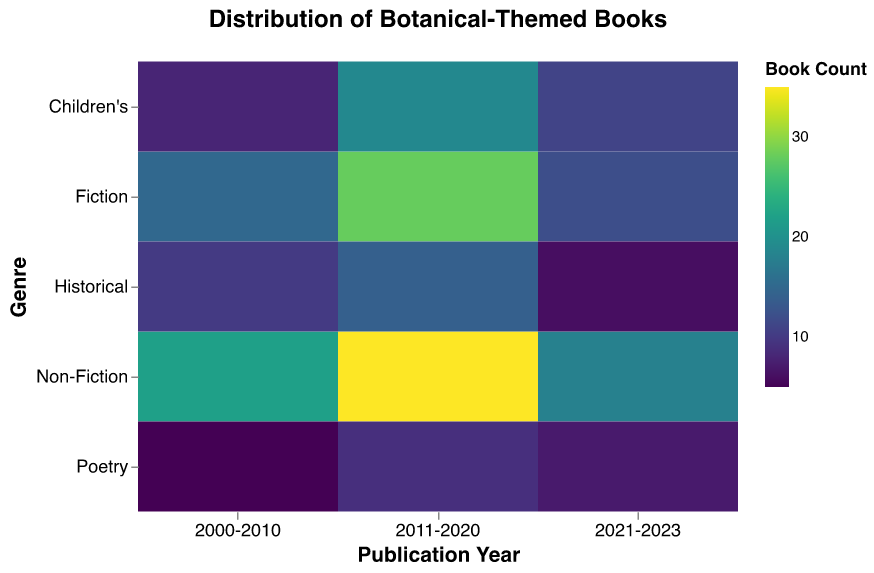What is the title of the figure? The title of the figure is typically displayed prominently at the top of the plot. It provides an overview of what the plot is depicting.
Answer: Distribution of Botanical-Themed Books Which genre has the highest number of botanical-themed books published between 2011-2020? To find this, look for the segment representing the year 2011-2020 and compare the color intensities corresponding to each genre. The darker the color, the higher the book count.
Answer: Non-Fiction How many botanical-themed Historical books were published between 2000-2010? Locate the "Historical" genre along the y-axis and then find the book count for the year 2000-2010 by identifying the color intensity.
Answer: 10 What is the total number of botanical-themed books published in Fiction between 2000-2023? Add the book counts for Fiction in each of the time periods provided: (15 from 2000-2010) + (28 from 2011-2020) + (12 from 2021-2023). Sum them up to get the total number of books.
Answer: 55 Which genre had the smallest number of botanical-themed books published between 2000-2010? Compare the color intensities of all segments for the years 2000-2010. The segment with the lightest color (lowest intensity) represents the smallest number of books.
Answer: Poetry Compare the total number of botanical-themed Non-Fiction books to the total number of botanical-themed Children's books across all years. Which genre had more books printed? Sum the book counts for Non-Fiction and Children's books across all provided time periods, then compare the totals. 
Non-Fiction: 22 (2000-2010) + 35 (2011-2020) + 18 (2021-2023) = 75
Children's: 8 (2000-2010) + 19 (2011-2020) + 11 (2021-2023) = 38
Thus, Non-Fiction has more.
Answer: Non-Fiction In which publication period did the Fiction genre have the lowest number of botanical-themed books published? Look at the "Fiction" genre and compare the color intensities for each publication period. The lightest color intensity indicates the lowest book count.
Answer: 2021-2023 Which genre had consistently increasing botanical-themed book counts over the years? For each genre, observe the book counts across the time periods. A genre with increasing counts will show progressively darker color intensities in sequential periods.
Answer: Children's How does the book count of botanical-themed Poetry books in 2021-2023 compare to the previous period? Compare the color intensities for Poetry between 2021-2023 and 2011-2020. Identify which period has the relatively darker color to determine the count.
Answer: Less 